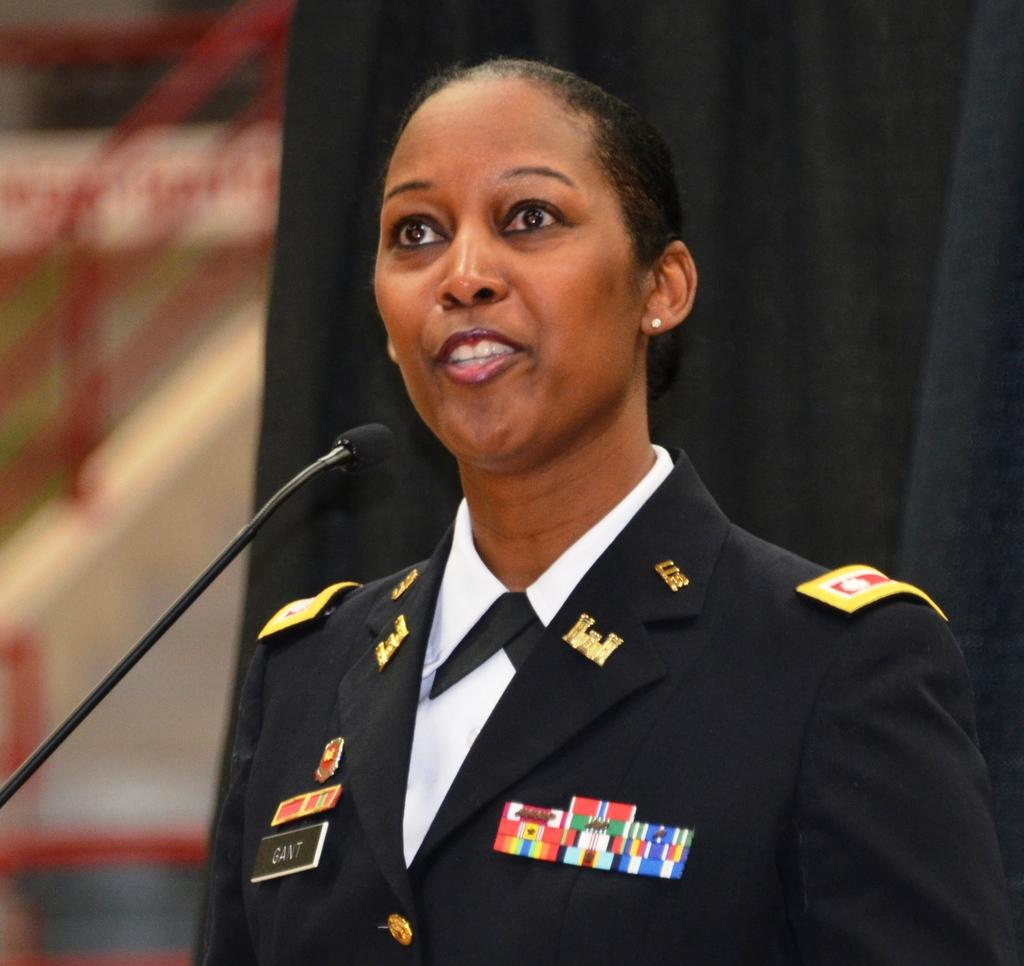Who is present in the image? There is a woman in the image. What is the woman wearing? The woman is wearing a uniform. What object can be seen near the woman? There is a microphone in the image. What color is the curtain in the background of the image? The curtain in the background of the image is black. How would you describe the background of the image? The background of the image is blurred. How many people are on vacation in the image? There is no indication of anyone being on vacation in the image. What type of stitch is used to create the woman's uniform? The image does not provide enough detail to determine the type of stitch used for the uniform. 